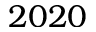<formula> <loc_0><loc_0><loc_500><loc_500>2 0 2 0</formula> 